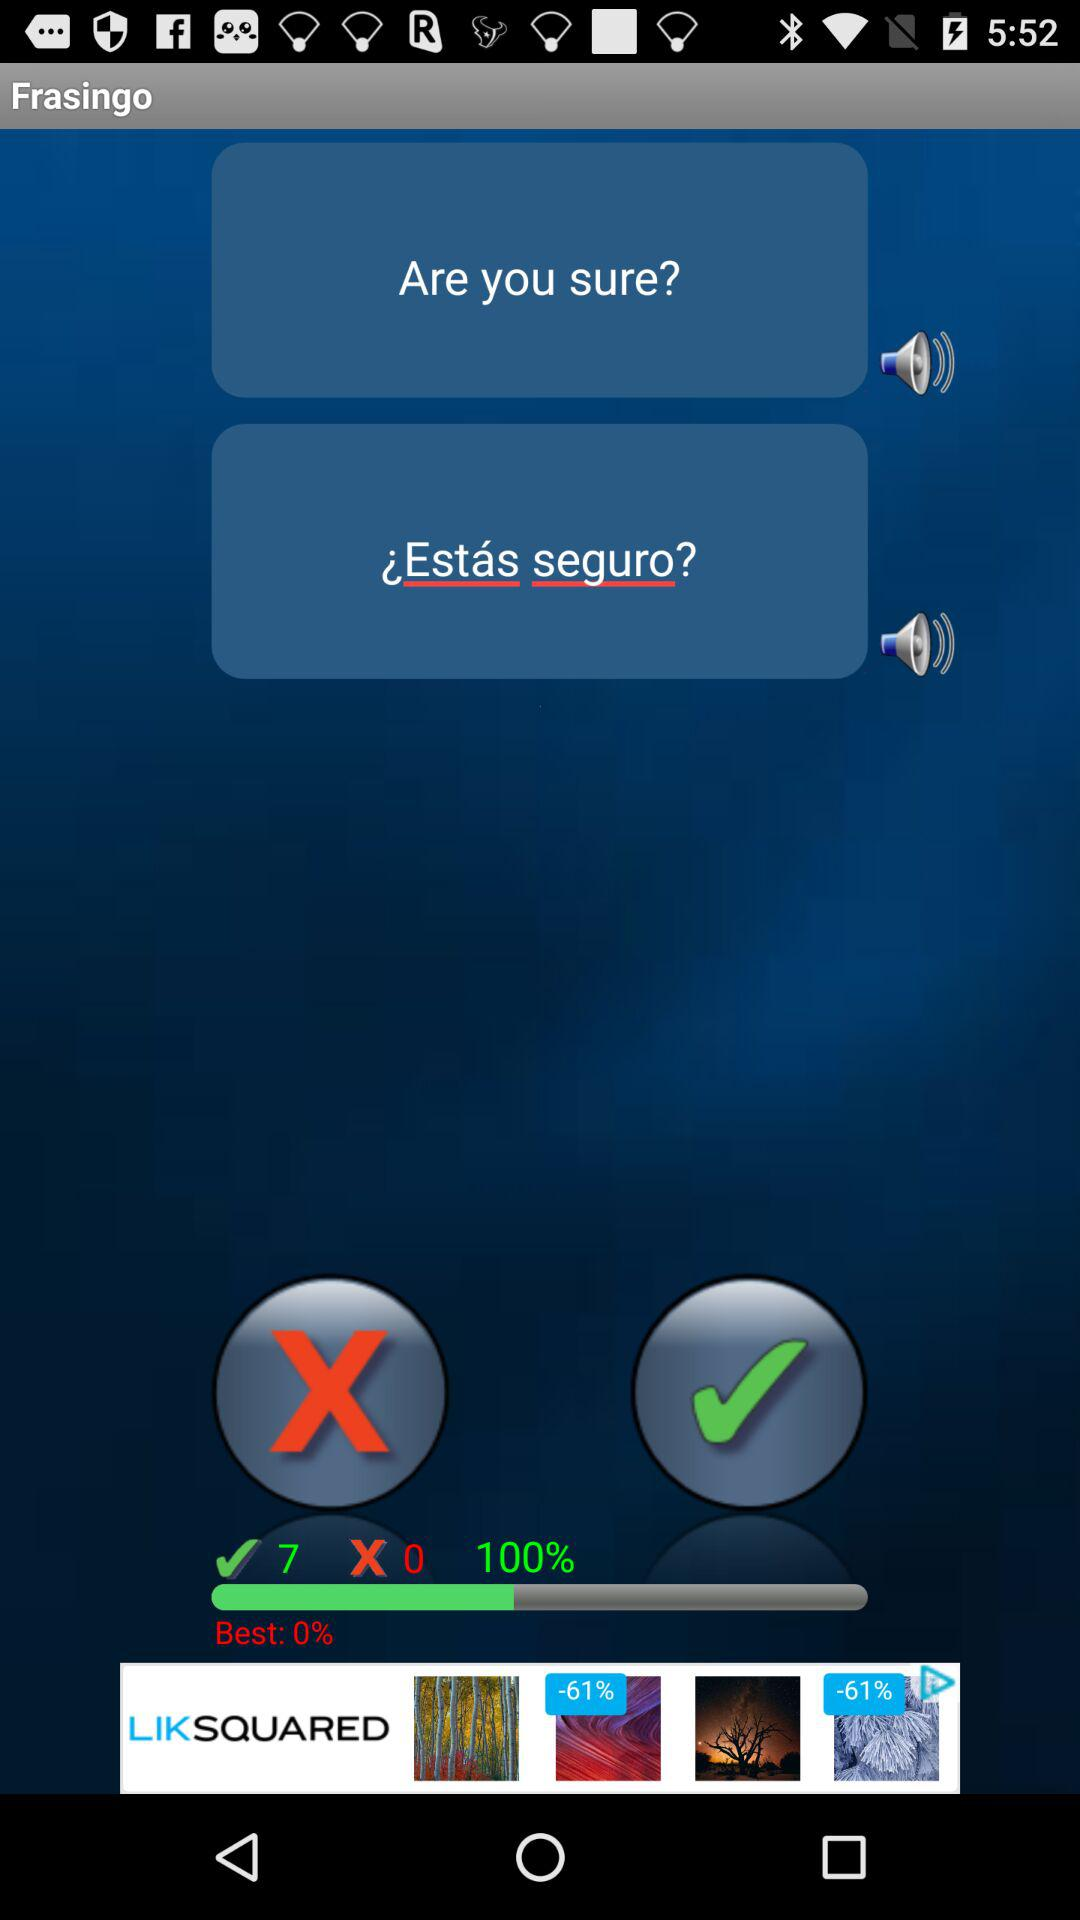What is the app name? The app name is "Frasingo". 